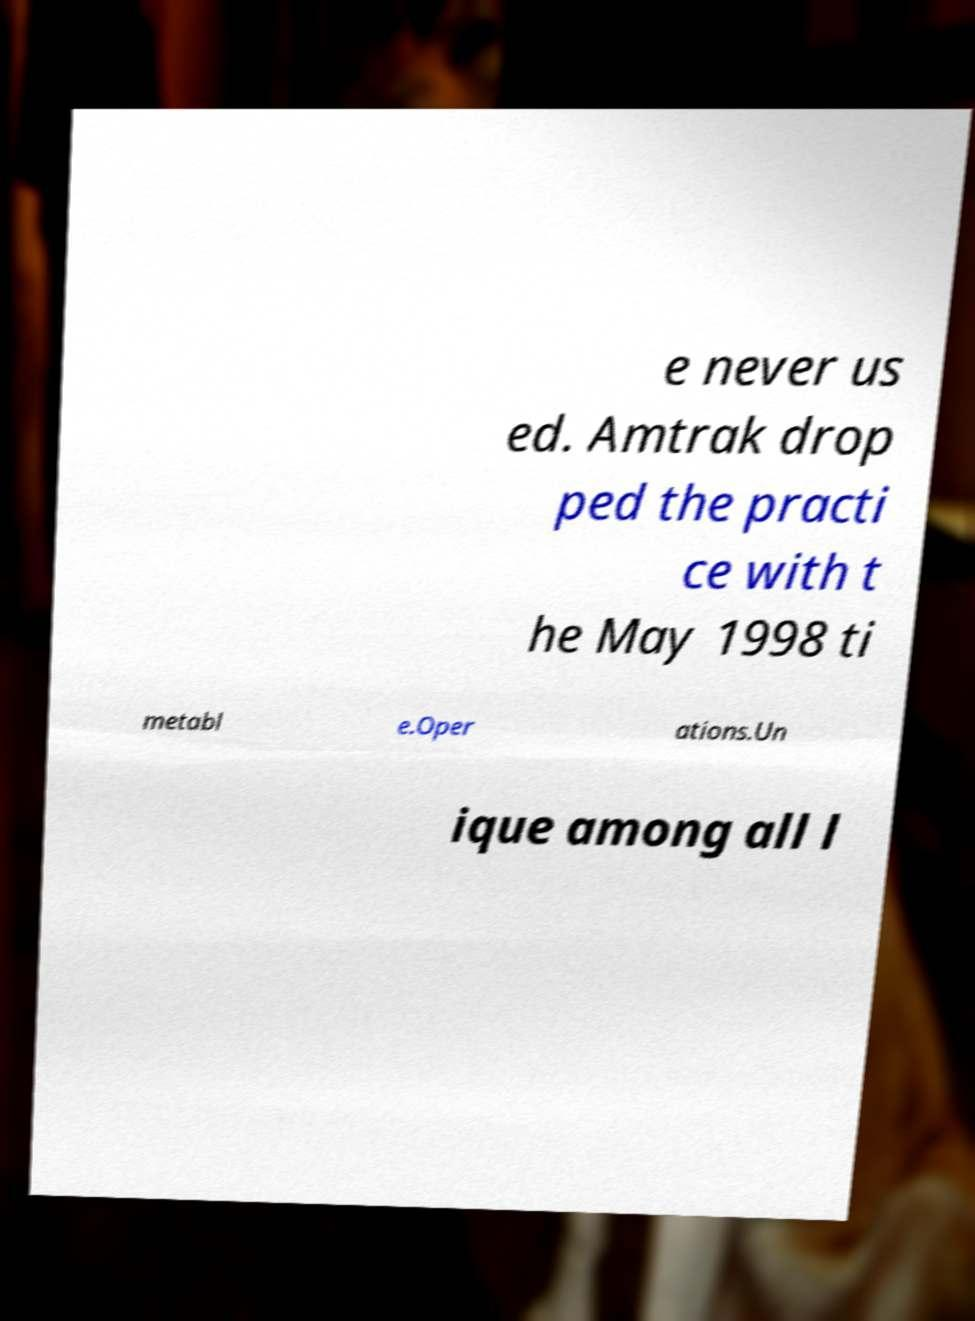Can you accurately transcribe the text from the provided image for me? e never us ed. Amtrak drop ped the practi ce with t he May 1998 ti metabl e.Oper ations.Un ique among all l 